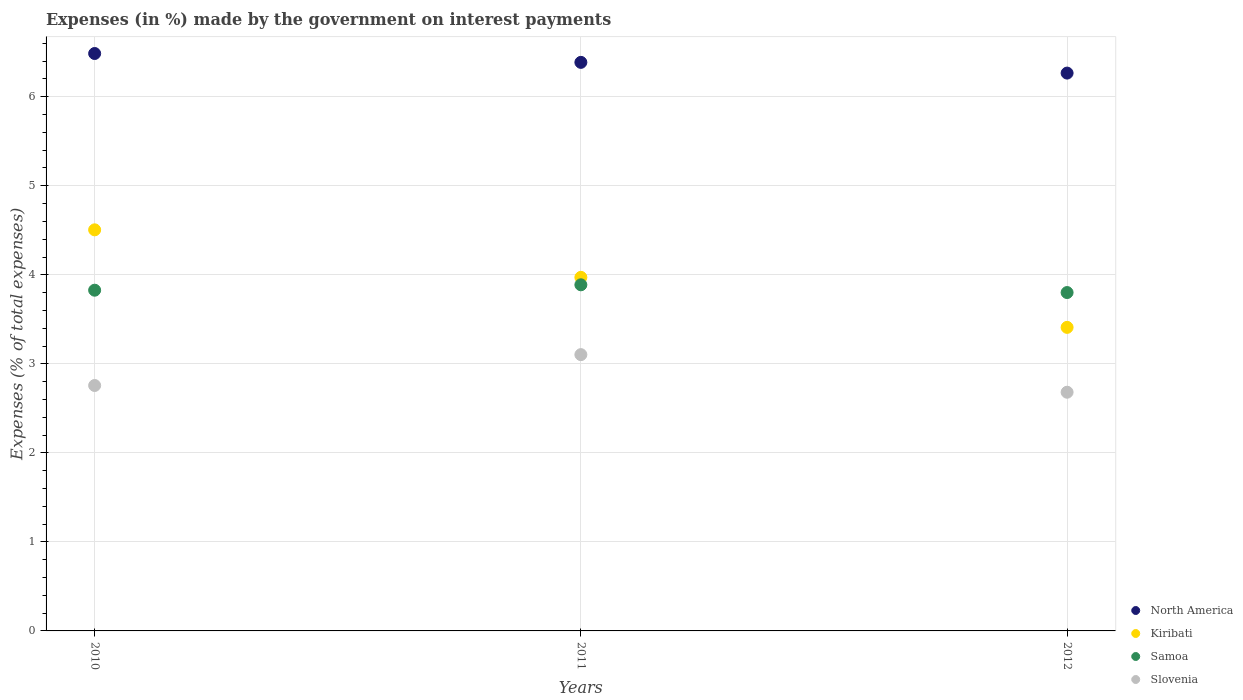How many different coloured dotlines are there?
Provide a short and direct response. 4. Is the number of dotlines equal to the number of legend labels?
Offer a terse response. Yes. What is the percentage of expenses made by the government on interest payments in Slovenia in 2011?
Keep it short and to the point. 3.1. Across all years, what is the maximum percentage of expenses made by the government on interest payments in North America?
Offer a very short reply. 6.49. Across all years, what is the minimum percentage of expenses made by the government on interest payments in Kiribati?
Your answer should be compact. 3.41. What is the total percentage of expenses made by the government on interest payments in North America in the graph?
Give a very brief answer. 19.14. What is the difference between the percentage of expenses made by the government on interest payments in Kiribati in 2010 and that in 2012?
Make the answer very short. 1.1. What is the difference between the percentage of expenses made by the government on interest payments in Kiribati in 2011 and the percentage of expenses made by the government on interest payments in North America in 2010?
Make the answer very short. -2.51. What is the average percentage of expenses made by the government on interest payments in Kiribati per year?
Make the answer very short. 3.96. In the year 2010, what is the difference between the percentage of expenses made by the government on interest payments in North America and percentage of expenses made by the government on interest payments in Kiribati?
Keep it short and to the point. 1.98. In how many years, is the percentage of expenses made by the government on interest payments in Slovenia greater than 2.4 %?
Your response must be concise. 3. What is the ratio of the percentage of expenses made by the government on interest payments in Slovenia in 2011 to that in 2012?
Your answer should be very brief. 1.16. Is the difference between the percentage of expenses made by the government on interest payments in North America in 2010 and 2012 greater than the difference between the percentage of expenses made by the government on interest payments in Kiribati in 2010 and 2012?
Offer a very short reply. No. What is the difference between the highest and the second highest percentage of expenses made by the government on interest payments in North America?
Keep it short and to the point. 0.1. What is the difference between the highest and the lowest percentage of expenses made by the government on interest payments in Samoa?
Keep it short and to the point. 0.09. Is it the case that in every year, the sum of the percentage of expenses made by the government on interest payments in Kiribati and percentage of expenses made by the government on interest payments in Slovenia  is greater than the sum of percentage of expenses made by the government on interest payments in North America and percentage of expenses made by the government on interest payments in Samoa?
Provide a short and direct response. No. Is it the case that in every year, the sum of the percentage of expenses made by the government on interest payments in Slovenia and percentage of expenses made by the government on interest payments in Kiribati  is greater than the percentage of expenses made by the government on interest payments in Samoa?
Make the answer very short. Yes. How many dotlines are there?
Make the answer very short. 4. What is the difference between two consecutive major ticks on the Y-axis?
Make the answer very short. 1. Are the values on the major ticks of Y-axis written in scientific E-notation?
Your response must be concise. No. Does the graph contain any zero values?
Offer a very short reply. No. How many legend labels are there?
Offer a terse response. 4. What is the title of the graph?
Ensure brevity in your answer.  Expenses (in %) made by the government on interest payments. What is the label or title of the X-axis?
Offer a terse response. Years. What is the label or title of the Y-axis?
Your answer should be very brief. Expenses (% of total expenses). What is the Expenses (% of total expenses) in North America in 2010?
Your response must be concise. 6.49. What is the Expenses (% of total expenses) of Kiribati in 2010?
Your response must be concise. 4.51. What is the Expenses (% of total expenses) of Samoa in 2010?
Your answer should be very brief. 3.83. What is the Expenses (% of total expenses) of Slovenia in 2010?
Provide a succinct answer. 2.76. What is the Expenses (% of total expenses) in North America in 2011?
Your answer should be compact. 6.39. What is the Expenses (% of total expenses) in Kiribati in 2011?
Make the answer very short. 3.97. What is the Expenses (% of total expenses) in Samoa in 2011?
Provide a short and direct response. 3.89. What is the Expenses (% of total expenses) in Slovenia in 2011?
Provide a short and direct response. 3.1. What is the Expenses (% of total expenses) of North America in 2012?
Your answer should be compact. 6.27. What is the Expenses (% of total expenses) of Kiribati in 2012?
Offer a very short reply. 3.41. What is the Expenses (% of total expenses) in Samoa in 2012?
Your answer should be very brief. 3.8. What is the Expenses (% of total expenses) of Slovenia in 2012?
Keep it short and to the point. 2.68. Across all years, what is the maximum Expenses (% of total expenses) of North America?
Ensure brevity in your answer.  6.49. Across all years, what is the maximum Expenses (% of total expenses) of Kiribati?
Your answer should be compact. 4.51. Across all years, what is the maximum Expenses (% of total expenses) of Samoa?
Your response must be concise. 3.89. Across all years, what is the maximum Expenses (% of total expenses) in Slovenia?
Give a very brief answer. 3.1. Across all years, what is the minimum Expenses (% of total expenses) in North America?
Give a very brief answer. 6.27. Across all years, what is the minimum Expenses (% of total expenses) of Kiribati?
Keep it short and to the point. 3.41. Across all years, what is the minimum Expenses (% of total expenses) in Samoa?
Offer a very short reply. 3.8. Across all years, what is the minimum Expenses (% of total expenses) of Slovenia?
Provide a succinct answer. 2.68. What is the total Expenses (% of total expenses) in North America in the graph?
Offer a terse response. 19.14. What is the total Expenses (% of total expenses) in Kiribati in the graph?
Offer a terse response. 11.89. What is the total Expenses (% of total expenses) of Samoa in the graph?
Give a very brief answer. 11.52. What is the total Expenses (% of total expenses) of Slovenia in the graph?
Your answer should be very brief. 8.54. What is the difference between the Expenses (% of total expenses) in North America in 2010 and that in 2011?
Your answer should be very brief. 0.1. What is the difference between the Expenses (% of total expenses) of Kiribati in 2010 and that in 2011?
Offer a terse response. 0.53. What is the difference between the Expenses (% of total expenses) of Samoa in 2010 and that in 2011?
Give a very brief answer. -0.06. What is the difference between the Expenses (% of total expenses) of Slovenia in 2010 and that in 2011?
Keep it short and to the point. -0.35. What is the difference between the Expenses (% of total expenses) in North America in 2010 and that in 2012?
Keep it short and to the point. 0.22. What is the difference between the Expenses (% of total expenses) in Kiribati in 2010 and that in 2012?
Your response must be concise. 1.1. What is the difference between the Expenses (% of total expenses) of Samoa in 2010 and that in 2012?
Your answer should be very brief. 0.03. What is the difference between the Expenses (% of total expenses) in Slovenia in 2010 and that in 2012?
Provide a succinct answer. 0.08. What is the difference between the Expenses (% of total expenses) of North America in 2011 and that in 2012?
Your answer should be compact. 0.12. What is the difference between the Expenses (% of total expenses) in Kiribati in 2011 and that in 2012?
Your answer should be compact. 0.56. What is the difference between the Expenses (% of total expenses) in Samoa in 2011 and that in 2012?
Give a very brief answer. 0.09. What is the difference between the Expenses (% of total expenses) of Slovenia in 2011 and that in 2012?
Give a very brief answer. 0.42. What is the difference between the Expenses (% of total expenses) in North America in 2010 and the Expenses (% of total expenses) in Kiribati in 2011?
Your response must be concise. 2.51. What is the difference between the Expenses (% of total expenses) in North America in 2010 and the Expenses (% of total expenses) in Samoa in 2011?
Give a very brief answer. 2.6. What is the difference between the Expenses (% of total expenses) of North America in 2010 and the Expenses (% of total expenses) of Slovenia in 2011?
Your response must be concise. 3.38. What is the difference between the Expenses (% of total expenses) in Kiribati in 2010 and the Expenses (% of total expenses) in Samoa in 2011?
Offer a very short reply. 0.62. What is the difference between the Expenses (% of total expenses) in Kiribati in 2010 and the Expenses (% of total expenses) in Slovenia in 2011?
Offer a terse response. 1.4. What is the difference between the Expenses (% of total expenses) in Samoa in 2010 and the Expenses (% of total expenses) in Slovenia in 2011?
Ensure brevity in your answer.  0.72. What is the difference between the Expenses (% of total expenses) in North America in 2010 and the Expenses (% of total expenses) in Kiribati in 2012?
Your answer should be very brief. 3.08. What is the difference between the Expenses (% of total expenses) in North America in 2010 and the Expenses (% of total expenses) in Samoa in 2012?
Ensure brevity in your answer.  2.69. What is the difference between the Expenses (% of total expenses) in North America in 2010 and the Expenses (% of total expenses) in Slovenia in 2012?
Make the answer very short. 3.8. What is the difference between the Expenses (% of total expenses) of Kiribati in 2010 and the Expenses (% of total expenses) of Samoa in 2012?
Provide a short and direct response. 0.7. What is the difference between the Expenses (% of total expenses) in Kiribati in 2010 and the Expenses (% of total expenses) in Slovenia in 2012?
Provide a short and direct response. 1.82. What is the difference between the Expenses (% of total expenses) in Samoa in 2010 and the Expenses (% of total expenses) in Slovenia in 2012?
Make the answer very short. 1.15. What is the difference between the Expenses (% of total expenses) in North America in 2011 and the Expenses (% of total expenses) in Kiribati in 2012?
Offer a very short reply. 2.98. What is the difference between the Expenses (% of total expenses) in North America in 2011 and the Expenses (% of total expenses) in Samoa in 2012?
Give a very brief answer. 2.59. What is the difference between the Expenses (% of total expenses) in North America in 2011 and the Expenses (% of total expenses) in Slovenia in 2012?
Ensure brevity in your answer.  3.71. What is the difference between the Expenses (% of total expenses) in Kiribati in 2011 and the Expenses (% of total expenses) in Samoa in 2012?
Your answer should be compact. 0.17. What is the difference between the Expenses (% of total expenses) in Kiribati in 2011 and the Expenses (% of total expenses) in Slovenia in 2012?
Give a very brief answer. 1.29. What is the difference between the Expenses (% of total expenses) of Samoa in 2011 and the Expenses (% of total expenses) of Slovenia in 2012?
Make the answer very short. 1.21. What is the average Expenses (% of total expenses) of North America per year?
Provide a short and direct response. 6.38. What is the average Expenses (% of total expenses) of Kiribati per year?
Your response must be concise. 3.96. What is the average Expenses (% of total expenses) of Samoa per year?
Your answer should be very brief. 3.84. What is the average Expenses (% of total expenses) of Slovenia per year?
Ensure brevity in your answer.  2.85. In the year 2010, what is the difference between the Expenses (% of total expenses) in North America and Expenses (% of total expenses) in Kiribati?
Your response must be concise. 1.98. In the year 2010, what is the difference between the Expenses (% of total expenses) of North America and Expenses (% of total expenses) of Samoa?
Offer a very short reply. 2.66. In the year 2010, what is the difference between the Expenses (% of total expenses) of North America and Expenses (% of total expenses) of Slovenia?
Your response must be concise. 3.73. In the year 2010, what is the difference between the Expenses (% of total expenses) in Kiribati and Expenses (% of total expenses) in Samoa?
Keep it short and to the point. 0.68. In the year 2010, what is the difference between the Expenses (% of total expenses) of Kiribati and Expenses (% of total expenses) of Slovenia?
Offer a terse response. 1.75. In the year 2010, what is the difference between the Expenses (% of total expenses) in Samoa and Expenses (% of total expenses) in Slovenia?
Offer a terse response. 1.07. In the year 2011, what is the difference between the Expenses (% of total expenses) in North America and Expenses (% of total expenses) in Kiribati?
Make the answer very short. 2.41. In the year 2011, what is the difference between the Expenses (% of total expenses) of North America and Expenses (% of total expenses) of Samoa?
Make the answer very short. 2.5. In the year 2011, what is the difference between the Expenses (% of total expenses) of North America and Expenses (% of total expenses) of Slovenia?
Offer a very short reply. 3.28. In the year 2011, what is the difference between the Expenses (% of total expenses) in Kiribati and Expenses (% of total expenses) in Samoa?
Your response must be concise. 0.08. In the year 2011, what is the difference between the Expenses (% of total expenses) in Kiribati and Expenses (% of total expenses) in Slovenia?
Keep it short and to the point. 0.87. In the year 2011, what is the difference between the Expenses (% of total expenses) of Samoa and Expenses (% of total expenses) of Slovenia?
Provide a succinct answer. 0.78. In the year 2012, what is the difference between the Expenses (% of total expenses) of North America and Expenses (% of total expenses) of Kiribati?
Give a very brief answer. 2.86. In the year 2012, what is the difference between the Expenses (% of total expenses) of North America and Expenses (% of total expenses) of Samoa?
Keep it short and to the point. 2.47. In the year 2012, what is the difference between the Expenses (% of total expenses) in North America and Expenses (% of total expenses) in Slovenia?
Your response must be concise. 3.58. In the year 2012, what is the difference between the Expenses (% of total expenses) of Kiribati and Expenses (% of total expenses) of Samoa?
Provide a succinct answer. -0.39. In the year 2012, what is the difference between the Expenses (% of total expenses) of Kiribati and Expenses (% of total expenses) of Slovenia?
Offer a terse response. 0.73. In the year 2012, what is the difference between the Expenses (% of total expenses) in Samoa and Expenses (% of total expenses) in Slovenia?
Your answer should be very brief. 1.12. What is the ratio of the Expenses (% of total expenses) in North America in 2010 to that in 2011?
Ensure brevity in your answer.  1.02. What is the ratio of the Expenses (% of total expenses) of Kiribati in 2010 to that in 2011?
Make the answer very short. 1.13. What is the ratio of the Expenses (% of total expenses) in Samoa in 2010 to that in 2011?
Your answer should be very brief. 0.98. What is the ratio of the Expenses (% of total expenses) of Slovenia in 2010 to that in 2011?
Your answer should be very brief. 0.89. What is the ratio of the Expenses (% of total expenses) in North America in 2010 to that in 2012?
Provide a succinct answer. 1.04. What is the ratio of the Expenses (% of total expenses) of Kiribati in 2010 to that in 2012?
Make the answer very short. 1.32. What is the ratio of the Expenses (% of total expenses) of Samoa in 2010 to that in 2012?
Your answer should be very brief. 1.01. What is the ratio of the Expenses (% of total expenses) of Slovenia in 2010 to that in 2012?
Your answer should be compact. 1.03. What is the ratio of the Expenses (% of total expenses) of North America in 2011 to that in 2012?
Ensure brevity in your answer.  1.02. What is the ratio of the Expenses (% of total expenses) of Kiribati in 2011 to that in 2012?
Provide a succinct answer. 1.16. What is the ratio of the Expenses (% of total expenses) of Samoa in 2011 to that in 2012?
Offer a very short reply. 1.02. What is the ratio of the Expenses (% of total expenses) in Slovenia in 2011 to that in 2012?
Offer a very short reply. 1.16. What is the difference between the highest and the second highest Expenses (% of total expenses) of North America?
Offer a very short reply. 0.1. What is the difference between the highest and the second highest Expenses (% of total expenses) of Kiribati?
Give a very brief answer. 0.53. What is the difference between the highest and the second highest Expenses (% of total expenses) of Samoa?
Your answer should be very brief. 0.06. What is the difference between the highest and the second highest Expenses (% of total expenses) in Slovenia?
Your response must be concise. 0.35. What is the difference between the highest and the lowest Expenses (% of total expenses) in North America?
Give a very brief answer. 0.22. What is the difference between the highest and the lowest Expenses (% of total expenses) of Kiribati?
Provide a short and direct response. 1.1. What is the difference between the highest and the lowest Expenses (% of total expenses) of Samoa?
Your answer should be compact. 0.09. What is the difference between the highest and the lowest Expenses (% of total expenses) of Slovenia?
Your answer should be compact. 0.42. 